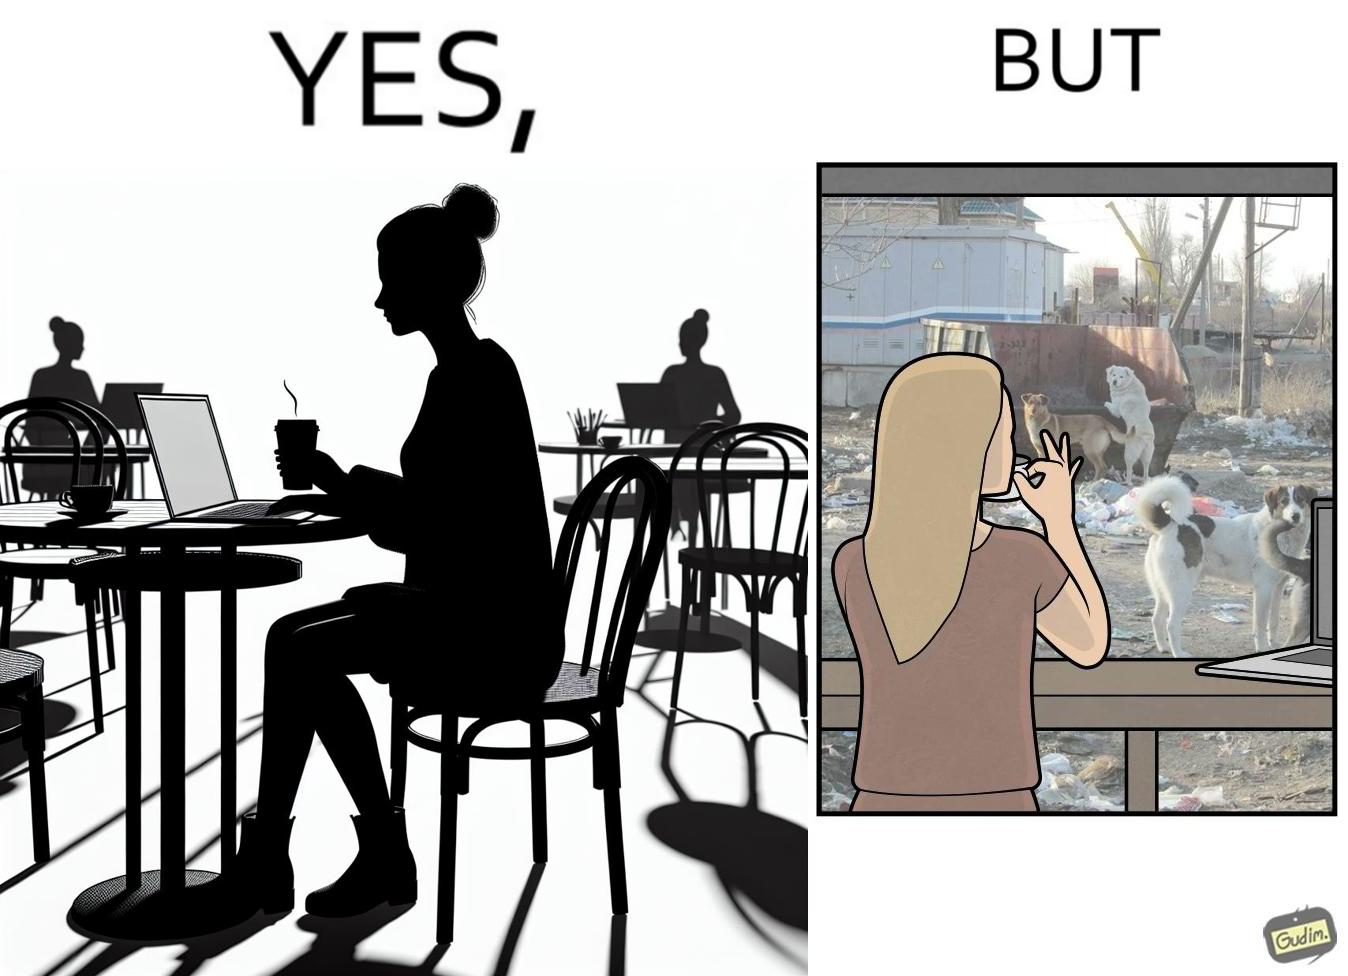Is this a satirical image? Yes, this image is satirical. 